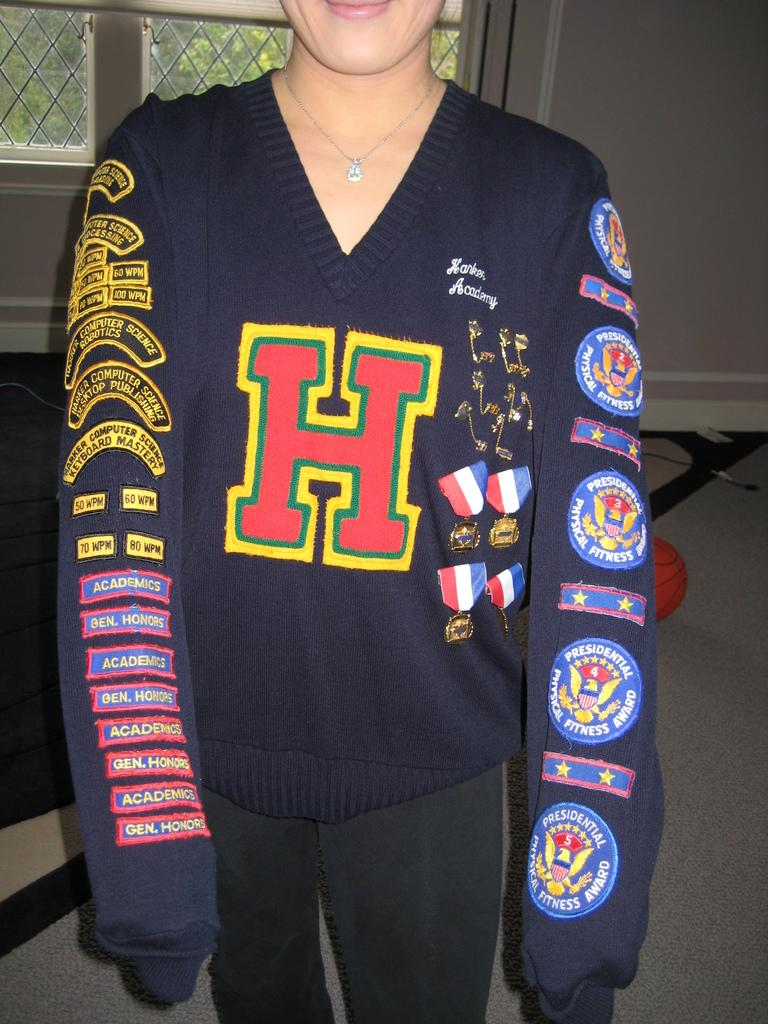Provide a one-sentence caption for the provided image. The blue high school sweater is covered in patches for the presidential physical fitness award and academic honors and is emblazoned with a large letter H. 